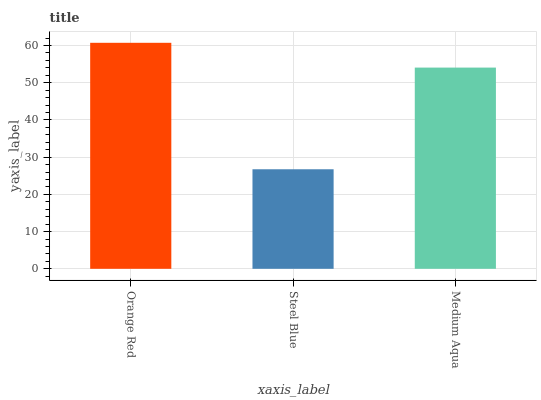Is Medium Aqua the minimum?
Answer yes or no. No. Is Medium Aqua the maximum?
Answer yes or no. No. Is Medium Aqua greater than Steel Blue?
Answer yes or no. Yes. Is Steel Blue less than Medium Aqua?
Answer yes or no. Yes. Is Steel Blue greater than Medium Aqua?
Answer yes or no. No. Is Medium Aqua less than Steel Blue?
Answer yes or no. No. Is Medium Aqua the high median?
Answer yes or no. Yes. Is Medium Aqua the low median?
Answer yes or no. Yes. Is Orange Red the high median?
Answer yes or no. No. Is Steel Blue the low median?
Answer yes or no. No. 